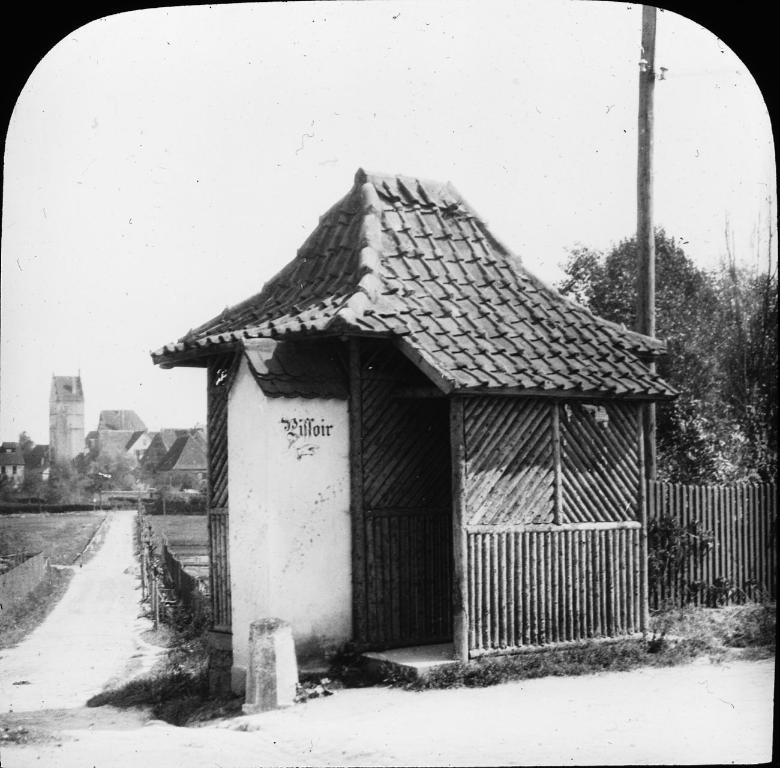How would you summarize this image in a sentence or two? In this image I can see the houses. On the right side, I can see the trees. I can also see the image is in black and white color. 